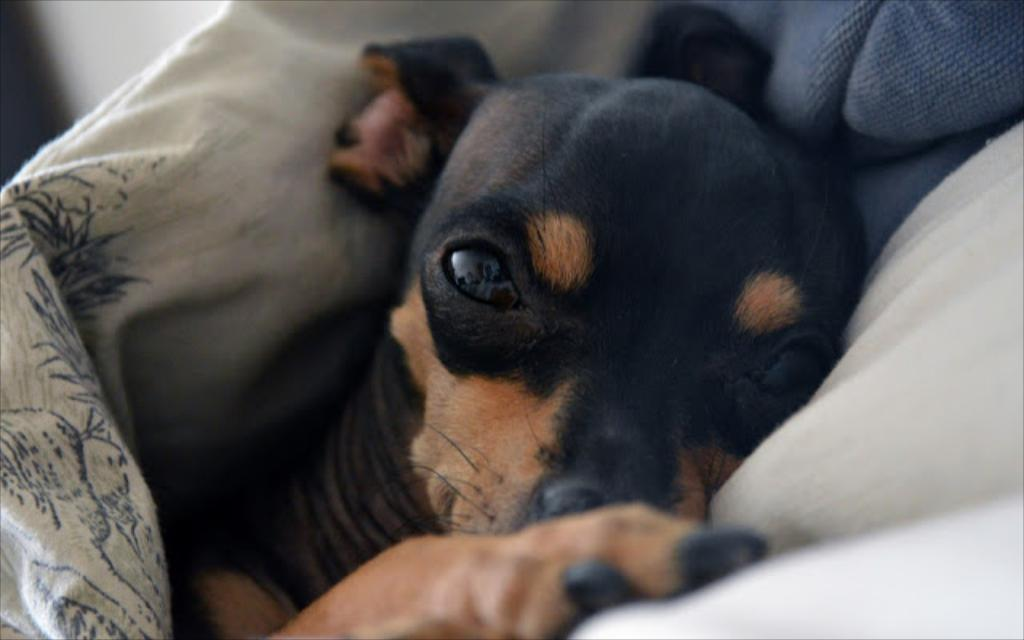What type of animal is in the image? There is a dog in the image. What colors can be seen on the dog's fur? The dog has black and brown coloring. What else can be seen in the image besides the dog? There are clothes visible in the image. Is the dog swimming in the image? There is no indication that the dog is swimming in the image; it is not depicted in water. 